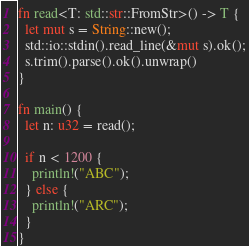<code> <loc_0><loc_0><loc_500><loc_500><_Rust_>fn read<T: std::str::FromStr>() -> T {
  let mut s = String::new();
  std::io::stdin().read_line(&mut s).ok();
  s.trim().parse().ok().unwrap()
}
 
fn main() {
  let n: u32 = read();

  if n < 1200 {
    println!("ABC");
  } else {
    println!("ARC");
  }
}
</code> 